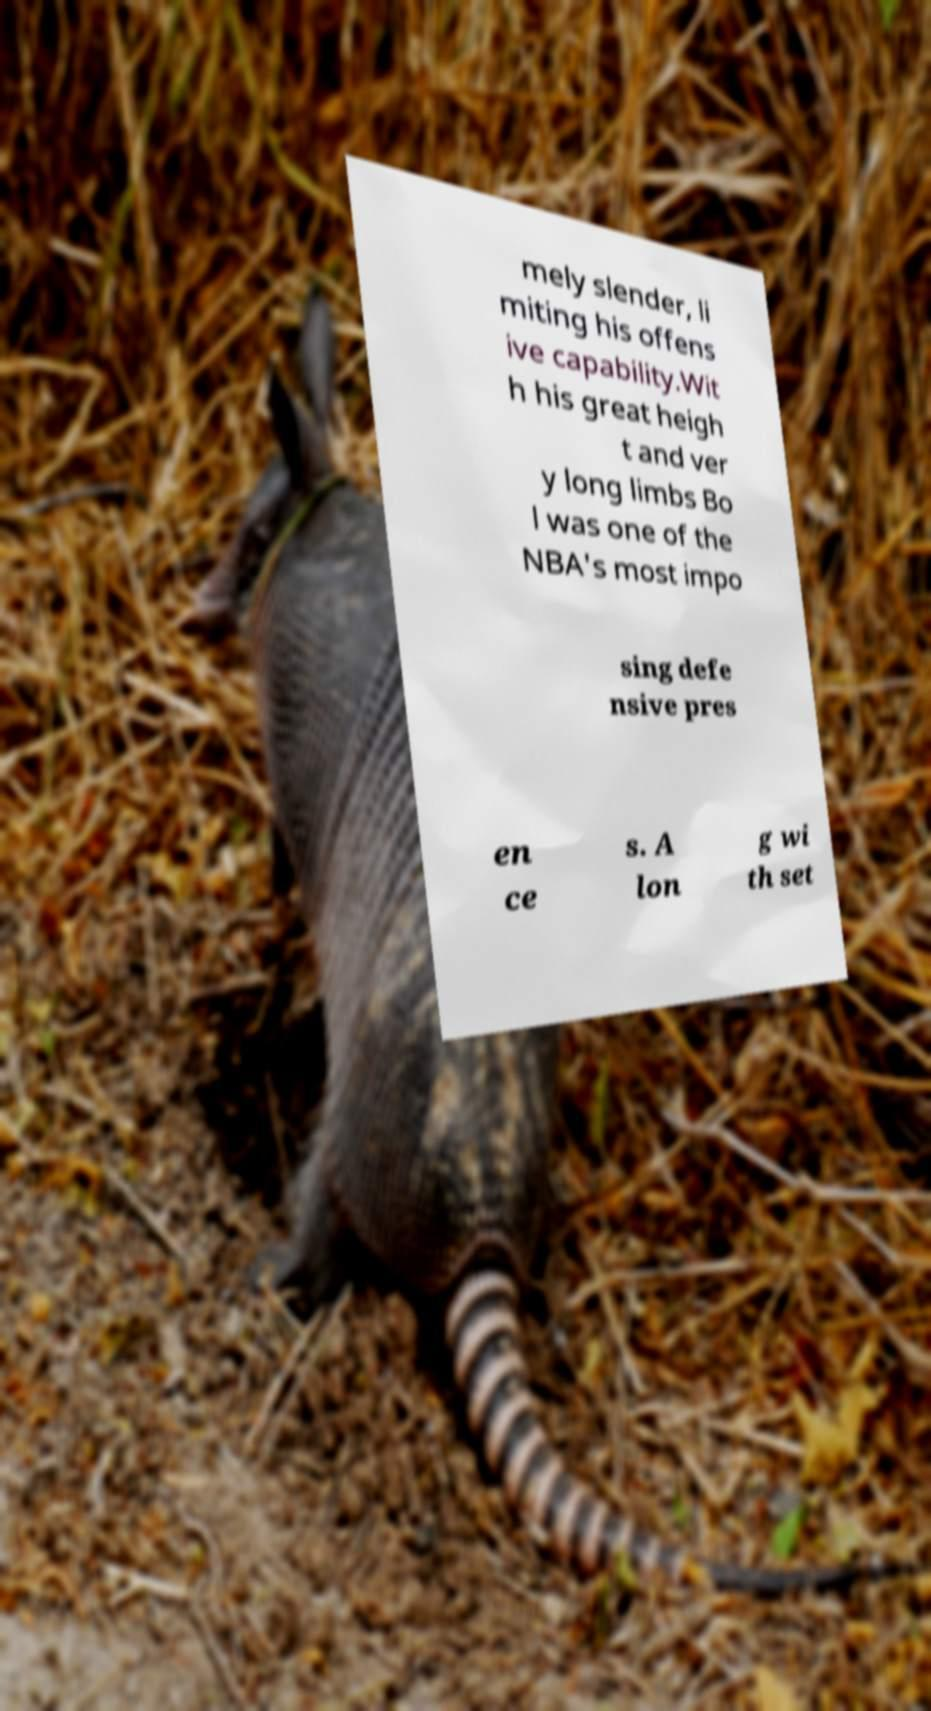Please read and relay the text visible in this image. What does it say? mely slender, li miting his offens ive capability.Wit h his great heigh t and ver y long limbs Bo l was one of the NBA's most impo sing defe nsive pres en ce s. A lon g wi th set 